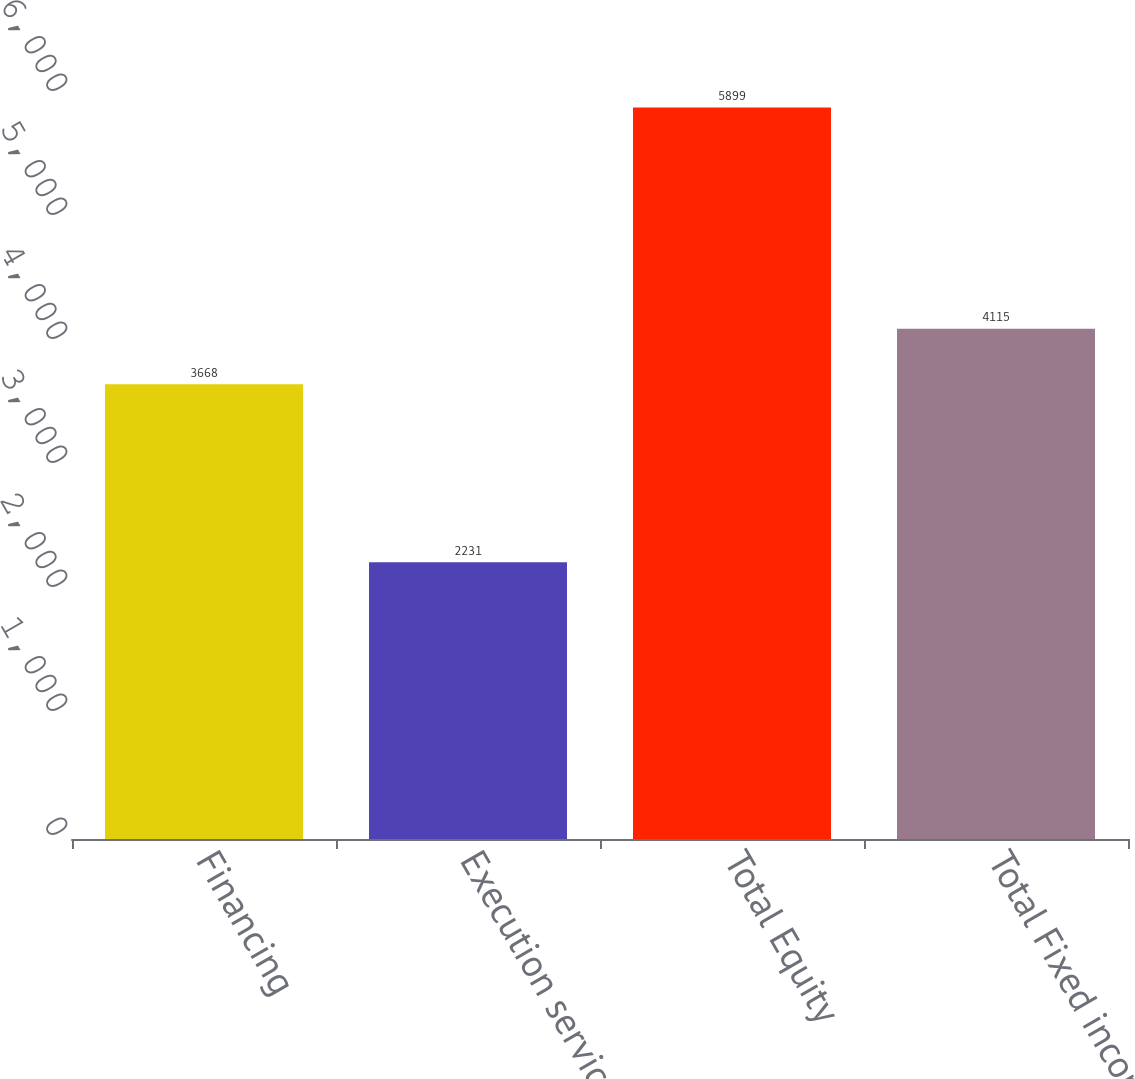Convert chart. <chart><loc_0><loc_0><loc_500><loc_500><bar_chart><fcel>Financing<fcel>Execution services<fcel>Total Equity<fcel>Total Fixed income<nl><fcel>3668<fcel>2231<fcel>5899<fcel>4115<nl></chart> 